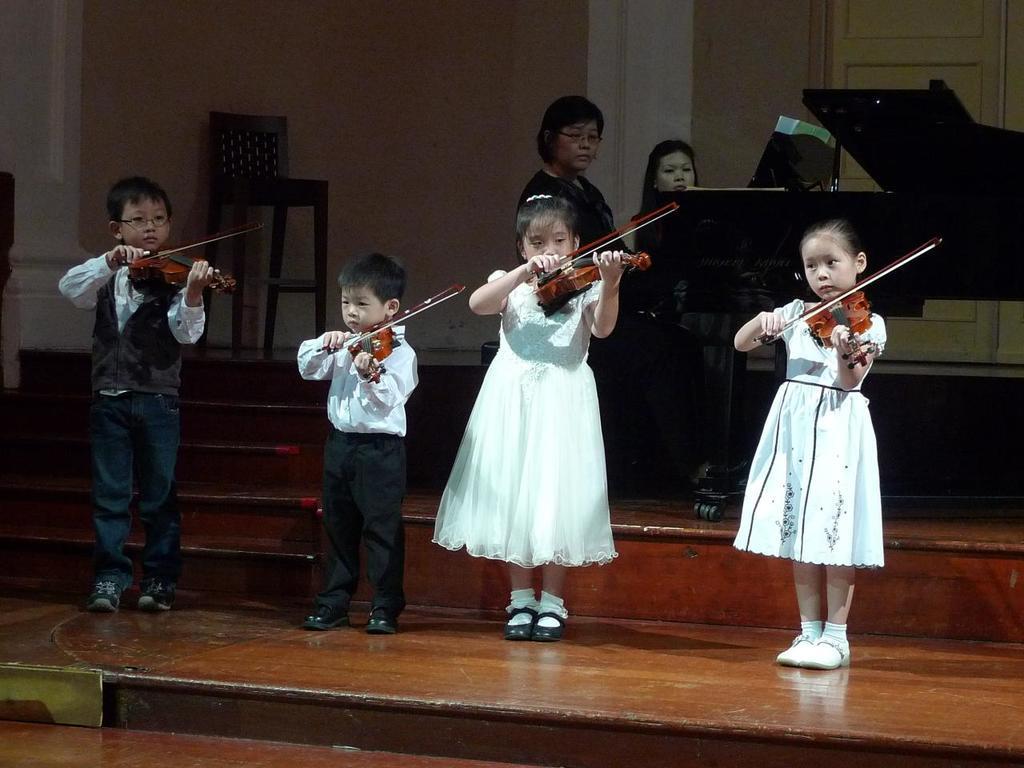In one or two sentences, can you explain what this image depicts? In this image i can see 4 kids holding violin in their hands. In the background i can see 2 women sitting in front of a piano and a wall. 